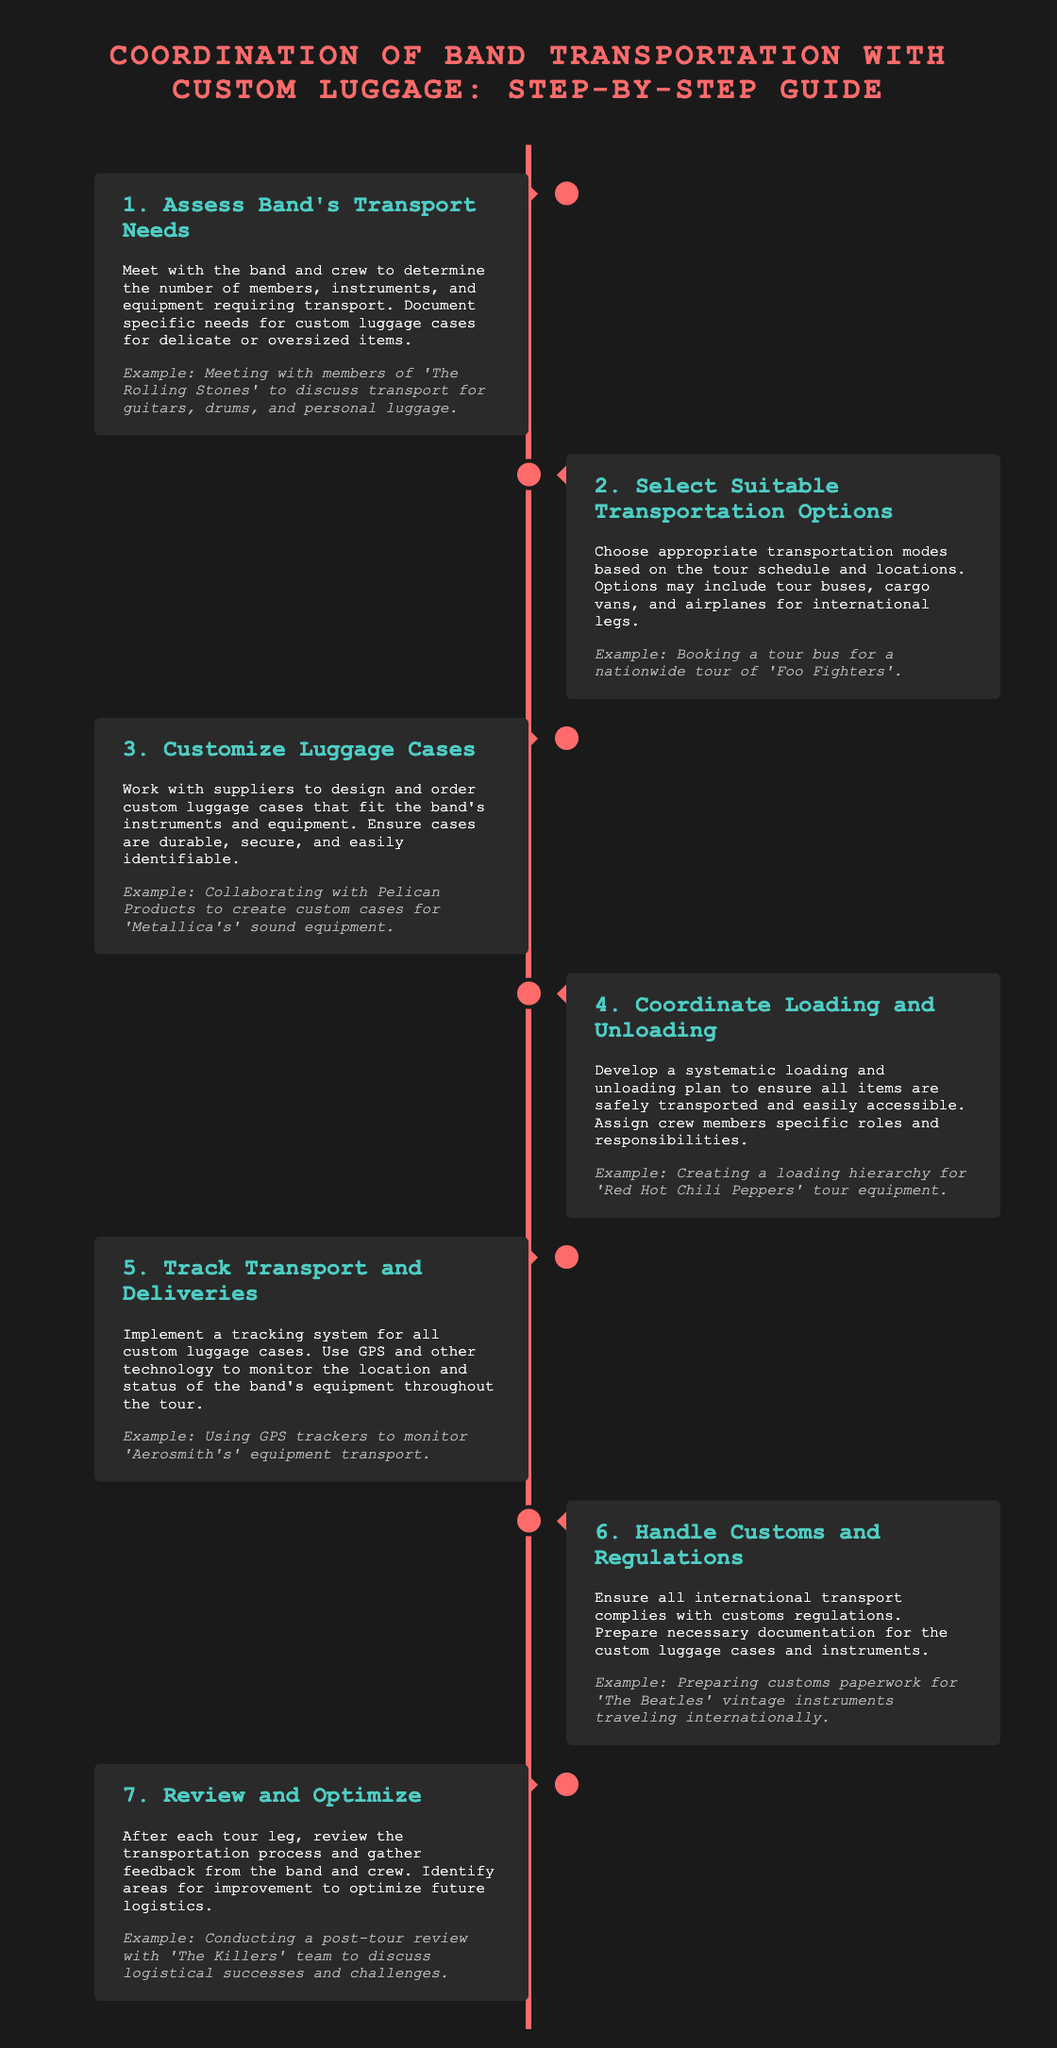what is the first step in the transportation process? The first step is to assess the band's transport needs, which involves meeting with the band and crew to determine their specific requirements.
Answer: Assess Band's Transport Needs which band example is given for customizing luggage cases? The example given for customizing luggage cases involves collaborating with Pelican Products to create custom cases for a specific band's equipment.
Answer: Metallica how many steps are outlined in the guide? The guide outlines a total of seven steps that detail the coordination of band transportation.
Answer: 7 what technology is suggested for tracking custom luggage cases? The guide suggests using GPS and other technology to monitor the location and status of the band's equipment.
Answer: GPS what is the purpose of step six in the coordination guide? Step six is focused on handling customs and regulations to ensure compliance during international transport.
Answer: Compliance what is the last step mentioned in the process? The last step in the process aims to review and optimize the transportation procedure after each tour leg.
Answer: Review and Optimize which band's logistics success is mentioned in the review process? The review process mentions conducting feedback with a specific band to discuss logistical successes and challenges.
Answer: The Killers what is an example of a transportation mode mentioned in the guide? The guide mentions various modes of transportation, providing an example related to a nationwide tour.
Answer: Tour bus 